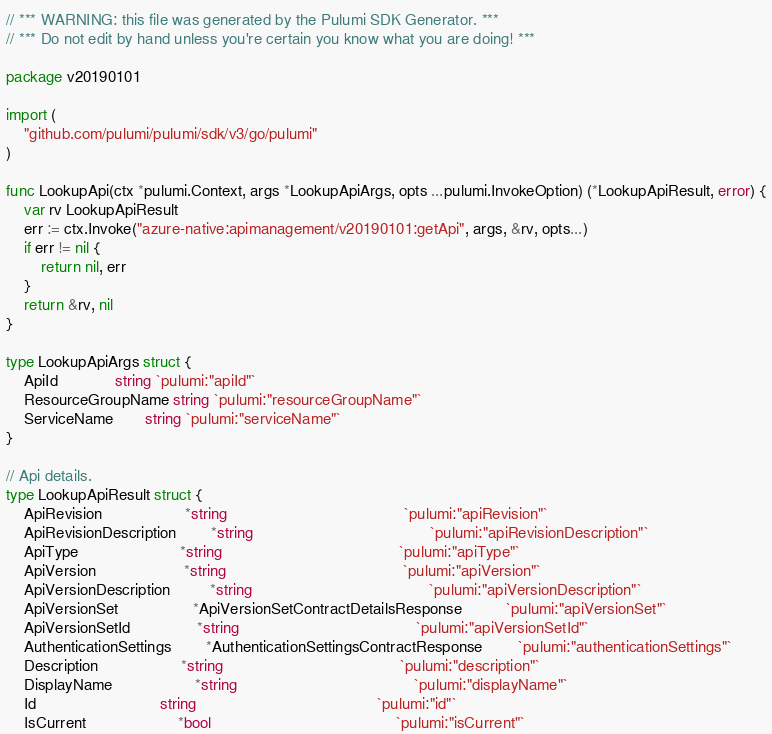Convert code to text. <code><loc_0><loc_0><loc_500><loc_500><_Go_>// *** WARNING: this file was generated by the Pulumi SDK Generator. ***
// *** Do not edit by hand unless you're certain you know what you are doing! ***

package v20190101

import (
	"github.com/pulumi/pulumi/sdk/v3/go/pulumi"
)

func LookupApi(ctx *pulumi.Context, args *LookupApiArgs, opts ...pulumi.InvokeOption) (*LookupApiResult, error) {
	var rv LookupApiResult
	err := ctx.Invoke("azure-native:apimanagement/v20190101:getApi", args, &rv, opts...)
	if err != nil {
		return nil, err
	}
	return &rv, nil
}

type LookupApiArgs struct {
	ApiId             string `pulumi:"apiId"`
	ResourceGroupName string `pulumi:"resourceGroupName"`
	ServiceName       string `pulumi:"serviceName"`
}

// Api details.
type LookupApiResult struct {
	ApiRevision                   *string                                        `pulumi:"apiRevision"`
	ApiRevisionDescription        *string                                        `pulumi:"apiRevisionDescription"`
	ApiType                       *string                                        `pulumi:"apiType"`
	ApiVersion                    *string                                        `pulumi:"apiVersion"`
	ApiVersionDescription         *string                                        `pulumi:"apiVersionDescription"`
	ApiVersionSet                 *ApiVersionSetContractDetailsResponse          `pulumi:"apiVersionSet"`
	ApiVersionSetId               *string                                        `pulumi:"apiVersionSetId"`
	AuthenticationSettings        *AuthenticationSettingsContractResponse        `pulumi:"authenticationSettings"`
	Description                   *string                                        `pulumi:"description"`
	DisplayName                   *string                                        `pulumi:"displayName"`
	Id                            string                                         `pulumi:"id"`
	IsCurrent                     *bool                                          `pulumi:"isCurrent"`</code> 